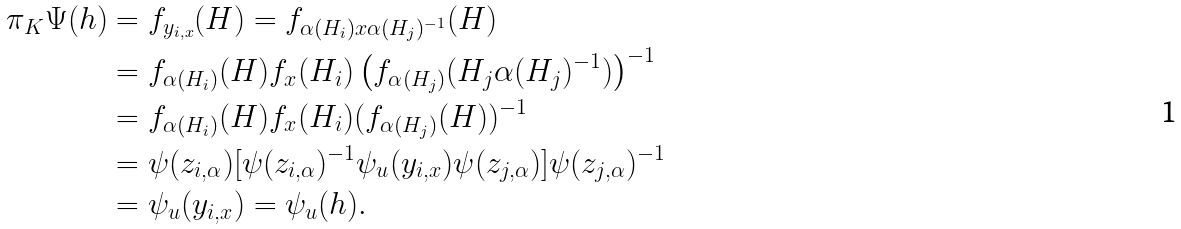Convert formula to latex. <formula><loc_0><loc_0><loc_500><loc_500>\pi _ { K } \Psi ( h ) & = f _ { y _ { i , x } } ( H ) = f _ { \alpha ( H _ { i } ) x \alpha ( H _ { j } ) ^ { - 1 } } ( H ) \\ & = f _ { \alpha ( H _ { i } ) } ( H ) f _ { x } ( H _ { i } ) \left ( f _ { \alpha ( H _ { j } ) } ( H _ { j } \alpha ( H _ { j } ) ^ { - 1 } ) \right ) ^ { - 1 } \\ & = f _ { \alpha ( H _ { i } ) } ( H ) f _ { x } ( H _ { i } ) ( f _ { \alpha ( H _ { j } ) } ( H ) ) ^ { - 1 } \\ & = \psi ( z _ { i , \alpha } ) [ \psi ( z _ { i , \alpha } ) ^ { - 1 } \psi _ { u } ( y _ { i , x } ) \psi ( z _ { j , \alpha } ) ] \psi ( z _ { j , \alpha } ) ^ { - 1 } \\ & = \psi _ { u } ( y _ { i , x } ) = \psi _ { u } ( h ) .</formula> 